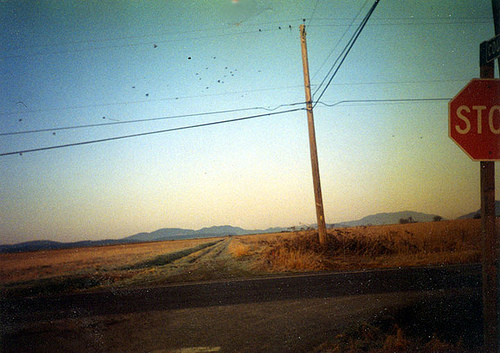Please transcribe the text in this image. STO 